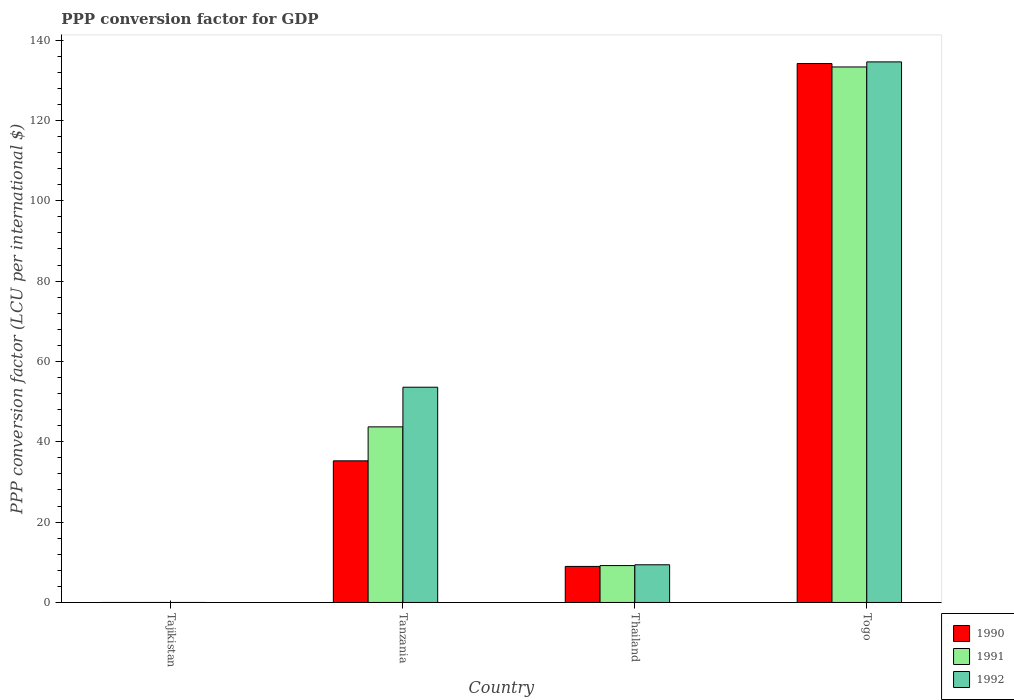How many groups of bars are there?
Make the answer very short. 4. Are the number of bars per tick equal to the number of legend labels?
Your response must be concise. Yes. What is the label of the 4th group of bars from the left?
Give a very brief answer. Togo. In how many cases, is the number of bars for a given country not equal to the number of legend labels?
Your answer should be very brief. 0. What is the PPP conversion factor for GDP in 1991 in Togo?
Provide a succinct answer. 133.31. Across all countries, what is the maximum PPP conversion factor for GDP in 1990?
Ensure brevity in your answer.  134.16. Across all countries, what is the minimum PPP conversion factor for GDP in 1992?
Make the answer very short. 7.45704164810197e-5. In which country was the PPP conversion factor for GDP in 1992 maximum?
Ensure brevity in your answer.  Togo. In which country was the PPP conversion factor for GDP in 1990 minimum?
Offer a terse response. Tajikistan. What is the total PPP conversion factor for GDP in 1990 in the graph?
Keep it short and to the point. 178.4. What is the difference between the PPP conversion factor for GDP in 1991 in Tanzania and that in Togo?
Provide a succinct answer. -89.6. What is the difference between the PPP conversion factor for GDP in 1990 in Tanzania and the PPP conversion factor for GDP in 1992 in Togo?
Give a very brief answer. -99.31. What is the average PPP conversion factor for GDP in 1992 per country?
Ensure brevity in your answer.  49.39. What is the difference between the PPP conversion factor for GDP of/in 1990 and PPP conversion factor for GDP of/in 1991 in Tanzania?
Offer a terse response. -8.46. In how many countries, is the PPP conversion factor for GDP in 1990 greater than 24 LCU?
Offer a terse response. 2. What is the ratio of the PPP conversion factor for GDP in 1992 in Tanzania to that in Togo?
Your answer should be compact. 0.4. Is the PPP conversion factor for GDP in 1991 in Tajikistan less than that in Tanzania?
Offer a very short reply. Yes. Is the difference between the PPP conversion factor for GDP in 1990 in Tanzania and Togo greater than the difference between the PPP conversion factor for GDP in 1991 in Tanzania and Togo?
Provide a short and direct response. No. What is the difference between the highest and the second highest PPP conversion factor for GDP in 1992?
Provide a short and direct response. -44.2. What is the difference between the highest and the lowest PPP conversion factor for GDP in 1992?
Offer a terse response. 134.57. In how many countries, is the PPP conversion factor for GDP in 1992 greater than the average PPP conversion factor for GDP in 1992 taken over all countries?
Your answer should be very brief. 2. What does the 3rd bar from the right in Tajikistan represents?
Provide a succinct answer. 1990. How many bars are there?
Offer a terse response. 12. Are all the bars in the graph horizontal?
Make the answer very short. No. How many countries are there in the graph?
Provide a succinct answer. 4. What is the difference between two consecutive major ticks on the Y-axis?
Provide a succinct answer. 20. Are the values on the major ticks of Y-axis written in scientific E-notation?
Your answer should be compact. No. Does the graph contain grids?
Provide a short and direct response. No. Where does the legend appear in the graph?
Your answer should be compact. Bottom right. How are the legend labels stacked?
Make the answer very short. Vertical. What is the title of the graph?
Ensure brevity in your answer.  PPP conversion factor for GDP. What is the label or title of the X-axis?
Make the answer very short. Country. What is the label or title of the Y-axis?
Your answer should be compact. PPP conversion factor (LCU per international $). What is the PPP conversion factor (LCU per international $) of 1990 in Tajikistan?
Ensure brevity in your answer.  5.85696825200666e-6. What is the PPP conversion factor (LCU per international $) of 1991 in Tajikistan?
Offer a very short reply. 1.13195054998771e-5. What is the PPP conversion factor (LCU per international $) in 1992 in Tajikistan?
Provide a short and direct response. 7.45704164810197e-5. What is the PPP conversion factor (LCU per international $) of 1990 in Tanzania?
Give a very brief answer. 35.26. What is the PPP conversion factor (LCU per international $) of 1991 in Tanzania?
Your answer should be very brief. 43.72. What is the PPP conversion factor (LCU per international $) in 1992 in Tanzania?
Your response must be concise. 53.59. What is the PPP conversion factor (LCU per international $) in 1990 in Thailand?
Give a very brief answer. 8.98. What is the PPP conversion factor (LCU per international $) of 1991 in Thailand?
Provide a succinct answer. 9.19. What is the PPP conversion factor (LCU per international $) in 1992 in Thailand?
Ensure brevity in your answer.  9.39. What is the PPP conversion factor (LCU per international $) of 1990 in Togo?
Provide a short and direct response. 134.16. What is the PPP conversion factor (LCU per international $) in 1991 in Togo?
Your answer should be very brief. 133.31. What is the PPP conversion factor (LCU per international $) of 1992 in Togo?
Offer a very short reply. 134.57. Across all countries, what is the maximum PPP conversion factor (LCU per international $) in 1990?
Give a very brief answer. 134.16. Across all countries, what is the maximum PPP conversion factor (LCU per international $) in 1991?
Your response must be concise. 133.31. Across all countries, what is the maximum PPP conversion factor (LCU per international $) of 1992?
Offer a very short reply. 134.57. Across all countries, what is the minimum PPP conversion factor (LCU per international $) in 1990?
Offer a terse response. 5.85696825200666e-6. Across all countries, what is the minimum PPP conversion factor (LCU per international $) of 1991?
Your answer should be compact. 1.13195054998771e-5. Across all countries, what is the minimum PPP conversion factor (LCU per international $) of 1992?
Offer a terse response. 7.45704164810197e-5. What is the total PPP conversion factor (LCU per international $) in 1990 in the graph?
Provide a short and direct response. 178.4. What is the total PPP conversion factor (LCU per international $) in 1991 in the graph?
Make the answer very short. 186.21. What is the total PPP conversion factor (LCU per international $) in 1992 in the graph?
Keep it short and to the point. 197.54. What is the difference between the PPP conversion factor (LCU per international $) of 1990 in Tajikistan and that in Tanzania?
Provide a short and direct response. -35.26. What is the difference between the PPP conversion factor (LCU per international $) of 1991 in Tajikistan and that in Tanzania?
Keep it short and to the point. -43.72. What is the difference between the PPP conversion factor (LCU per international $) in 1992 in Tajikistan and that in Tanzania?
Provide a succinct answer. -53.59. What is the difference between the PPP conversion factor (LCU per international $) in 1990 in Tajikistan and that in Thailand?
Ensure brevity in your answer.  -8.98. What is the difference between the PPP conversion factor (LCU per international $) of 1991 in Tajikistan and that in Thailand?
Ensure brevity in your answer.  -9.19. What is the difference between the PPP conversion factor (LCU per international $) in 1992 in Tajikistan and that in Thailand?
Your response must be concise. -9.39. What is the difference between the PPP conversion factor (LCU per international $) of 1990 in Tajikistan and that in Togo?
Offer a very short reply. -134.16. What is the difference between the PPP conversion factor (LCU per international $) of 1991 in Tajikistan and that in Togo?
Keep it short and to the point. -133.31. What is the difference between the PPP conversion factor (LCU per international $) in 1992 in Tajikistan and that in Togo?
Provide a succinct answer. -134.57. What is the difference between the PPP conversion factor (LCU per international $) in 1990 in Tanzania and that in Thailand?
Your answer should be compact. 26.28. What is the difference between the PPP conversion factor (LCU per international $) in 1991 in Tanzania and that in Thailand?
Make the answer very short. 34.53. What is the difference between the PPP conversion factor (LCU per international $) of 1992 in Tanzania and that in Thailand?
Make the answer very short. 44.2. What is the difference between the PPP conversion factor (LCU per international $) in 1990 in Tanzania and that in Togo?
Give a very brief answer. -98.91. What is the difference between the PPP conversion factor (LCU per international $) in 1991 in Tanzania and that in Togo?
Ensure brevity in your answer.  -89.6. What is the difference between the PPP conversion factor (LCU per international $) in 1992 in Tanzania and that in Togo?
Your answer should be compact. -80.98. What is the difference between the PPP conversion factor (LCU per international $) in 1990 in Thailand and that in Togo?
Offer a very short reply. -125.19. What is the difference between the PPP conversion factor (LCU per international $) of 1991 in Thailand and that in Togo?
Your answer should be very brief. -124.12. What is the difference between the PPP conversion factor (LCU per international $) in 1992 in Thailand and that in Togo?
Offer a very short reply. -125.18. What is the difference between the PPP conversion factor (LCU per international $) in 1990 in Tajikistan and the PPP conversion factor (LCU per international $) in 1991 in Tanzania?
Provide a short and direct response. -43.72. What is the difference between the PPP conversion factor (LCU per international $) of 1990 in Tajikistan and the PPP conversion factor (LCU per international $) of 1992 in Tanzania?
Provide a short and direct response. -53.59. What is the difference between the PPP conversion factor (LCU per international $) of 1991 in Tajikistan and the PPP conversion factor (LCU per international $) of 1992 in Tanzania?
Keep it short and to the point. -53.59. What is the difference between the PPP conversion factor (LCU per international $) in 1990 in Tajikistan and the PPP conversion factor (LCU per international $) in 1991 in Thailand?
Offer a very short reply. -9.19. What is the difference between the PPP conversion factor (LCU per international $) in 1990 in Tajikistan and the PPP conversion factor (LCU per international $) in 1992 in Thailand?
Keep it short and to the point. -9.39. What is the difference between the PPP conversion factor (LCU per international $) in 1991 in Tajikistan and the PPP conversion factor (LCU per international $) in 1992 in Thailand?
Offer a very short reply. -9.39. What is the difference between the PPP conversion factor (LCU per international $) of 1990 in Tajikistan and the PPP conversion factor (LCU per international $) of 1991 in Togo?
Your answer should be very brief. -133.31. What is the difference between the PPP conversion factor (LCU per international $) in 1990 in Tajikistan and the PPP conversion factor (LCU per international $) in 1992 in Togo?
Provide a short and direct response. -134.57. What is the difference between the PPP conversion factor (LCU per international $) in 1991 in Tajikistan and the PPP conversion factor (LCU per international $) in 1992 in Togo?
Offer a terse response. -134.57. What is the difference between the PPP conversion factor (LCU per international $) in 1990 in Tanzania and the PPP conversion factor (LCU per international $) in 1991 in Thailand?
Ensure brevity in your answer.  26.07. What is the difference between the PPP conversion factor (LCU per international $) of 1990 in Tanzania and the PPP conversion factor (LCU per international $) of 1992 in Thailand?
Provide a short and direct response. 25.87. What is the difference between the PPP conversion factor (LCU per international $) of 1991 in Tanzania and the PPP conversion factor (LCU per international $) of 1992 in Thailand?
Offer a very short reply. 34.33. What is the difference between the PPP conversion factor (LCU per international $) in 1990 in Tanzania and the PPP conversion factor (LCU per international $) in 1991 in Togo?
Keep it short and to the point. -98.05. What is the difference between the PPP conversion factor (LCU per international $) in 1990 in Tanzania and the PPP conversion factor (LCU per international $) in 1992 in Togo?
Your answer should be compact. -99.31. What is the difference between the PPP conversion factor (LCU per international $) in 1991 in Tanzania and the PPP conversion factor (LCU per international $) in 1992 in Togo?
Your response must be concise. -90.85. What is the difference between the PPP conversion factor (LCU per international $) in 1990 in Thailand and the PPP conversion factor (LCU per international $) in 1991 in Togo?
Provide a succinct answer. -124.33. What is the difference between the PPP conversion factor (LCU per international $) in 1990 in Thailand and the PPP conversion factor (LCU per international $) in 1992 in Togo?
Offer a terse response. -125.59. What is the difference between the PPP conversion factor (LCU per international $) of 1991 in Thailand and the PPP conversion factor (LCU per international $) of 1992 in Togo?
Ensure brevity in your answer.  -125.38. What is the average PPP conversion factor (LCU per international $) in 1990 per country?
Provide a short and direct response. 44.6. What is the average PPP conversion factor (LCU per international $) of 1991 per country?
Provide a succinct answer. 46.55. What is the average PPP conversion factor (LCU per international $) in 1992 per country?
Provide a short and direct response. 49.39. What is the difference between the PPP conversion factor (LCU per international $) in 1990 and PPP conversion factor (LCU per international $) in 1991 in Tajikistan?
Your response must be concise. -0. What is the difference between the PPP conversion factor (LCU per international $) in 1990 and PPP conversion factor (LCU per international $) in 1992 in Tajikistan?
Your answer should be compact. -0. What is the difference between the PPP conversion factor (LCU per international $) of 1991 and PPP conversion factor (LCU per international $) of 1992 in Tajikistan?
Offer a terse response. -0. What is the difference between the PPP conversion factor (LCU per international $) of 1990 and PPP conversion factor (LCU per international $) of 1991 in Tanzania?
Your answer should be very brief. -8.46. What is the difference between the PPP conversion factor (LCU per international $) of 1990 and PPP conversion factor (LCU per international $) of 1992 in Tanzania?
Your answer should be compact. -18.33. What is the difference between the PPP conversion factor (LCU per international $) in 1991 and PPP conversion factor (LCU per international $) in 1992 in Tanzania?
Your answer should be compact. -9.87. What is the difference between the PPP conversion factor (LCU per international $) of 1990 and PPP conversion factor (LCU per international $) of 1991 in Thailand?
Ensure brevity in your answer.  -0.21. What is the difference between the PPP conversion factor (LCU per international $) of 1990 and PPP conversion factor (LCU per international $) of 1992 in Thailand?
Make the answer very short. -0.41. What is the difference between the PPP conversion factor (LCU per international $) in 1991 and PPP conversion factor (LCU per international $) in 1992 in Thailand?
Your answer should be compact. -0.2. What is the difference between the PPP conversion factor (LCU per international $) in 1990 and PPP conversion factor (LCU per international $) in 1991 in Togo?
Offer a terse response. 0.85. What is the difference between the PPP conversion factor (LCU per international $) in 1990 and PPP conversion factor (LCU per international $) in 1992 in Togo?
Your answer should be compact. -0.41. What is the difference between the PPP conversion factor (LCU per international $) of 1991 and PPP conversion factor (LCU per international $) of 1992 in Togo?
Give a very brief answer. -1.26. What is the ratio of the PPP conversion factor (LCU per international $) of 1990 in Tajikistan to that in Tanzania?
Offer a very short reply. 0. What is the ratio of the PPP conversion factor (LCU per international $) in 1992 in Tajikistan to that in Tanzania?
Offer a terse response. 0. What is the ratio of the PPP conversion factor (LCU per international $) of 1990 in Tajikistan to that in Thailand?
Offer a terse response. 0. What is the ratio of the PPP conversion factor (LCU per international $) in 1991 in Tajikistan to that in Thailand?
Provide a succinct answer. 0. What is the ratio of the PPP conversion factor (LCU per international $) of 1992 in Tajikistan to that in Togo?
Your response must be concise. 0. What is the ratio of the PPP conversion factor (LCU per international $) of 1990 in Tanzania to that in Thailand?
Provide a short and direct response. 3.93. What is the ratio of the PPP conversion factor (LCU per international $) in 1991 in Tanzania to that in Thailand?
Provide a short and direct response. 4.76. What is the ratio of the PPP conversion factor (LCU per international $) in 1992 in Tanzania to that in Thailand?
Provide a short and direct response. 5.71. What is the ratio of the PPP conversion factor (LCU per international $) of 1990 in Tanzania to that in Togo?
Ensure brevity in your answer.  0.26. What is the ratio of the PPP conversion factor (LCU per international $) of 1991 in Tanzania to that in Togo?
Give a very brief answer. 0.33. What is the ratio of the PPP conversion factor (LCU per international $) of 1992 in Tanzania to that in Togo?
Provide a succinct answer. 0.4. What is the ratio of the PPP conversion factor (LCU per international $) in 1990 in Thailand to that in Togo?
Ensure brevity in your answer.  0.07. What is the ratio of the PPP conversion factor (LCU per international $) in 1991 in Thailand to that in Togo?
Your answer should be very brief. 0.07. What is the ratio of the PPP conversion factor (LCU per international $) of 1992 in Thailand to that in Togo?
Ensure brevity in your answer.  0.07. What is the difference between the highest and the second highest PPP conversion factor (LCU per international $) of 1990?
Make the answer very short. 98.91. What is the difference between the highest and the second highest PPP conversion factor (LCU per international $) in 1991?
Your answer should be compact. 89.6. What is the difference between the highest and the second highest PPP conversion factor (LCU per international $) in 1992?
Give a very brief answer. 80.98. What is the difference between the highest and the lowest PPP conversion factor (LCU per international $) of 1990?
Provide a succinct answer. 134.16. What is the difference between the highest and the lowest PPP conversion factor (LCU per international $) of 1991?
Your answer should be very brief. 133.31. What is the difference between the highest and the lowest PPP conversion factor (LCU per international $) in 1992?
Offer a terse response. 134.57. 